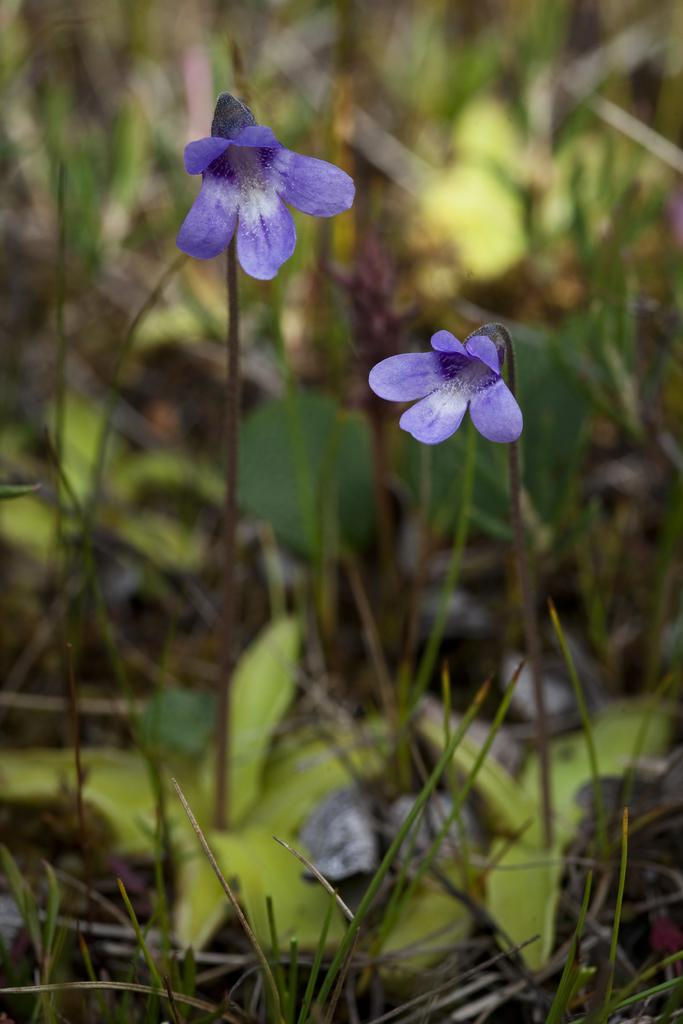What type of living organisms can be seen in the image? There are flowers and plants in the image. Can you describe the background of the image? The background of the image is blurry. What type of chain is being used for driving in the image? There is no chain or driving present in the image; it features flowers and plants with a blurry background. 